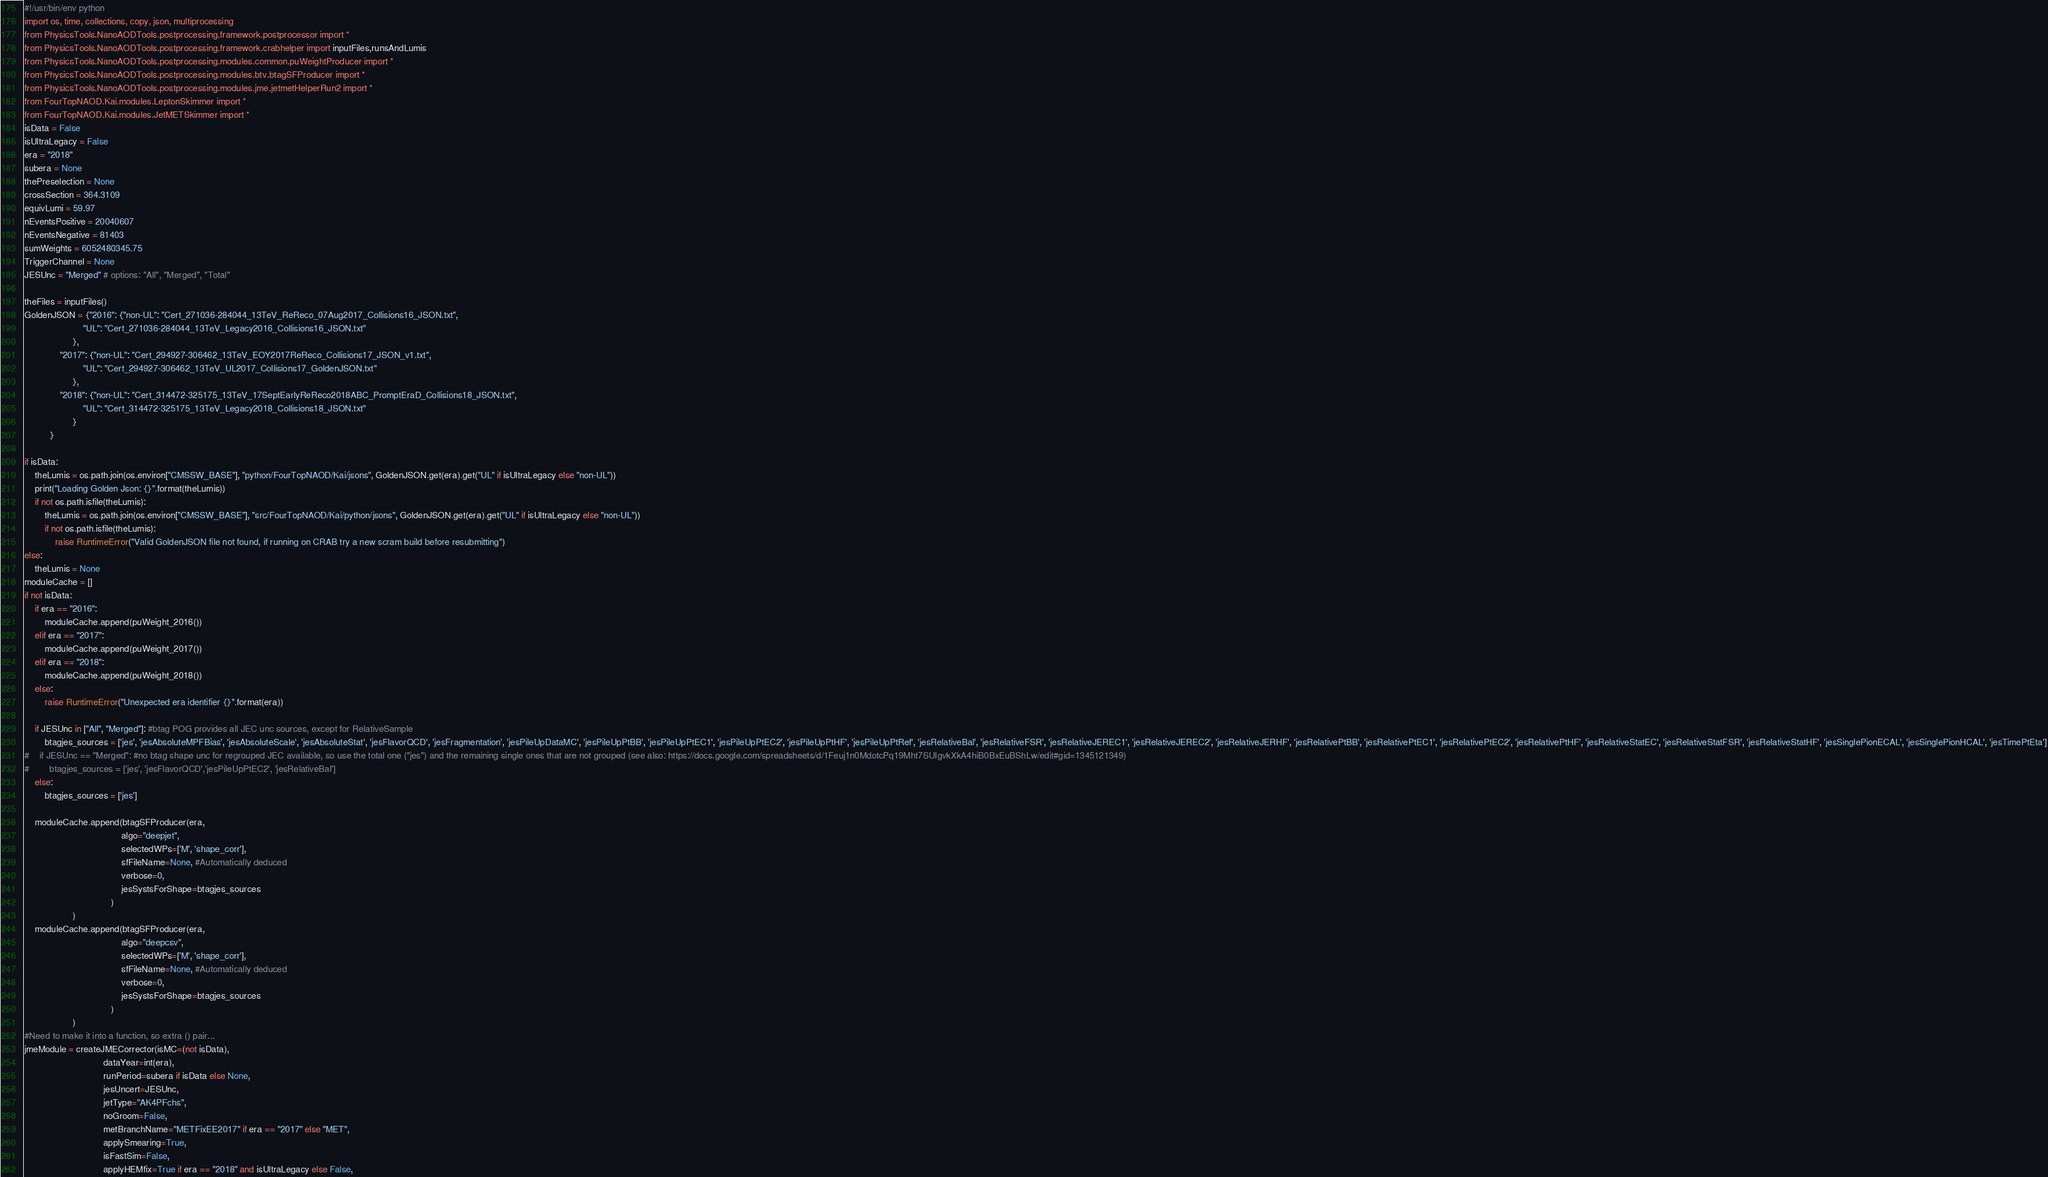<code> <loc_0><loc_0><loc_500><loc_500><_Python_>#!/usr/bin/env python
import os, time, collections, copy, json, multiprocessing
from PhysicsTools.NanoAODTools.postprocessing.framework.postprocessor import * 
from PhysicsTools.NanoAODTools.postprocessing.framework.crabhelper import inputFiles,runsAndLumis
from PhysicsTools.NanoAODTools.postprocessing.modules.common.puWeightProducer import *
from PhysicsTools.NanoAODTools.postprocessing.modules.btv.btagSFProducer import *
from PhysicsTools.NanoAODTools.postprocessing.modules.jme.jetmetHelperRun2 import *
from FourTopNAOD.Kai.modules.LeptonSkimmer import *
from FourTopNAOD.Kai.modules.JetMETSkimmer import *
isData = False
isUltraLegacy = False
era = "2018"
subera = None
thePreselection = None
crossSection = 364.3109
equivLumi = 59.97
nEventsPositive = 20040607
nEventsNegative = 81403
sumWeights = 6052480345.75
TriggerChannel = None
JESUnc = "Merged" # options: "All", "Merged", "Total"

theFiles = inputFiles()
GoldenJSON = {"2016": {"non-UL": "Cert_271036-284044_13TeV_ReReco_07Aug2017_Collisions16_JSON.txt",
                       "UL": "Cert_271036-284044_13TeV_Legacy2016_Collisions16_JSON.txt"
                   },
              "2017": {"non-UL": "Cert_294927-306462_13TeV_EOY2017ReReco_Collisions17_JSON_v1.txt",
                       "UL": "Cert_294927-306462_13TeV_UL2017_Collisions17_GoldenJSON.txt"
                   },
              "2018": {"non-UL": "Cert_314472-325175_13TeV_17SeptEarlyReReco2018ABC_PromptEraD_Collisions18_JSON.txt",
                       "UL": "Cert_314472-325175_13TeV_Legacy2018_Collisions18_JSON.txt"
                   }
          }

if isData:
    theLumis = os.path.join(os.environ["CMSSW_BASE"], "python/FourTopNAOD/Kai/jsons", GoldenJSON.get(era).get("UL" if isUltraLegacy else "non-UL"))
    print("Loading Golden Json: {}".format(theLumis))
    if not os.path.isfile(theLumis):
        theLumis = os.path.join(os.environ["CMSSW_BASE"], "src/FourTopNAOD/Kai/python/jsons", GoldenJSON.get(era).get("UL" if isUltraLegacy else "non-UL"))
        if not os.path.isfile(theLumis):
            raise RuntimeError("Valid GoldenJSON file not found, if running on CRAB try a new scram build before resubmitting")
else:
    theLumis = None
moduleCache = []
if not isData: 
    if era == "2016": 
        moduleCache.append(puWeight_2016())
    elif era == "2017": 
        moduleCache.append(puWeight_2017())
    elif era == "2018": 
        moduleCache.append(puWeight_2018())
    else:
        raise RuntimeError("Unexpected era identifier {}".format(era))
    
    if JESUnc in ["All", "Merged"]: #btag POG provides all JEC unc sources, except for RelativeSample
        btagjes_sources = ['jes', 'jesAbsoluteMPFBias', 'jesAbsoluteScale', 'jesAbsoluteStat', 'jesFlavorQCD', 'jesFragmentation', 'jesPileUpDataMC', 'jesPileUpPtBB', 'jesPileUpPtEC1', 'jesPileUpPtEC2', 'jesPileUpPtHF', 'jesPileUpPtRef', 'jesRelativeBal', 'jesRelativeFSR', 'jesRelativeJEREC1', 'jesRelativeJEREC2', 'jesRelativeJERHF', 'jesRelativePtBB', 'jesRelativePtEC1', 'jesRelativePtEC2', 'jesRelativePtHF', 'jesRelativeStatEC', 'jesRelativeStatFSR', 'jesRelativeStatHF', 'jesSinglePionECAL', 'jesSinglePionHCAL', 'jesTimePtEta']
#    if JESUnc == "Merged": #no btag shape unc for regrouped JEC available, so use the total one ("jes") and the remaining single ones that are not grouped (see also: https://docs.google.com/spreadsheets/d/1Feuj1n0MdotcPq19Mht7SUIgvkXkA4hiB0BxEuBShLw/edit#gid=1345121349)
#        btagjes_sources = ['jes', 'jesFlavorQCD','jesPileUpPtEC2', 'jesRelativeBal']
    else:
        btagjes_sources = ['jes']

    moduleCache.append(btagSFProducer(era,
                                      algo="deepjet",
                                      selectedWPs=['M', 'shape_corr'],
                                      sfFileName=None, #Automatically deduced
                                      verbose=0,
                                      jesSystsForShape=btagjes_sources
                                  )
                   )
    moduleCache.append(btagSFProducer(era,
                                      algo="deepcsv",
                                      selectedWPs=['M', 'shape_corr'],
                                      sfFileName=None, #Automatically deduced
                                      verbose=0,
                                      jesSystsForShape=btagjes_sources
                                  )
                   )
#Need to make it into a function, so extra () pair...
jmeModule = createJMECorrector(isMC=(not isData), 
                               dataYear=int(era), 
                               runPeriod=subera if isData else None, 
                               jesUncert=JESUnc, 
                               jetType="AK4PFchs", 
                               noGroom=False, 
                               metBranchName="METFixEE2017" if era == "2017" else "MET",
                               applySmearing=True, 
                               isFastSim=False, 
                               applyHEMfix=True if era == "2018" and isUltraLegacy else False, </code> 